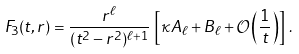Convert formula to latex. <formula><loc_0><loc_0><loc_500><loc_500>F _ { 3 } ( t , r ) = \frac { r ^ { \ell } } { ( t ^ { 2 } - r ^ { 2 } ) ^ { \ell + 1 } } \, \left [ \kappa A _ { \ell } + B _ { \ell } + \mathcal { O } \left ( \frac { 1 } { t } \right ) \right ] \, .</formula> 